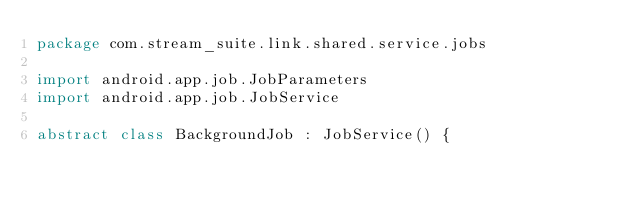<code> <loc_0><loc_0><loc_500><loc_500><_Kotlin_>package com.stream_suite.link.shared.service.jobs

import android.app.job.JobParameters
import android.app.job.JobService

abstract class BackgroundJob : JobService() {
</code> 